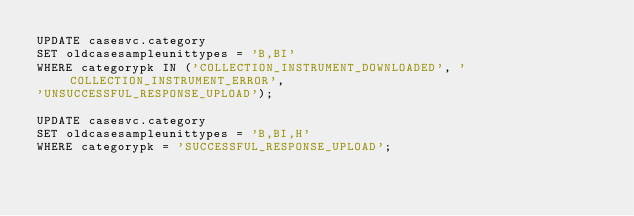<code> <loc_0><loc_0><loc_500><loc_500><_SQL_>UPDATE casesvc.category
SET oldcasesampleunittypes = 'B,BI'
WHERE categorypk IN ('COLLECTION_INSTRUMENT_DOWNLOADED', 'COLLECTION_INSTRUMENT_ERROR',
'UNSUCCESSFUL_RESPONSE_UPLOAD');

UPDATE casesvc.category
SET oldcasesampleunittypes = 'B,BI,H'
WHERE categorypk = 'SUCCESSFUL_RESPONSE_UPLOAD';</code> 